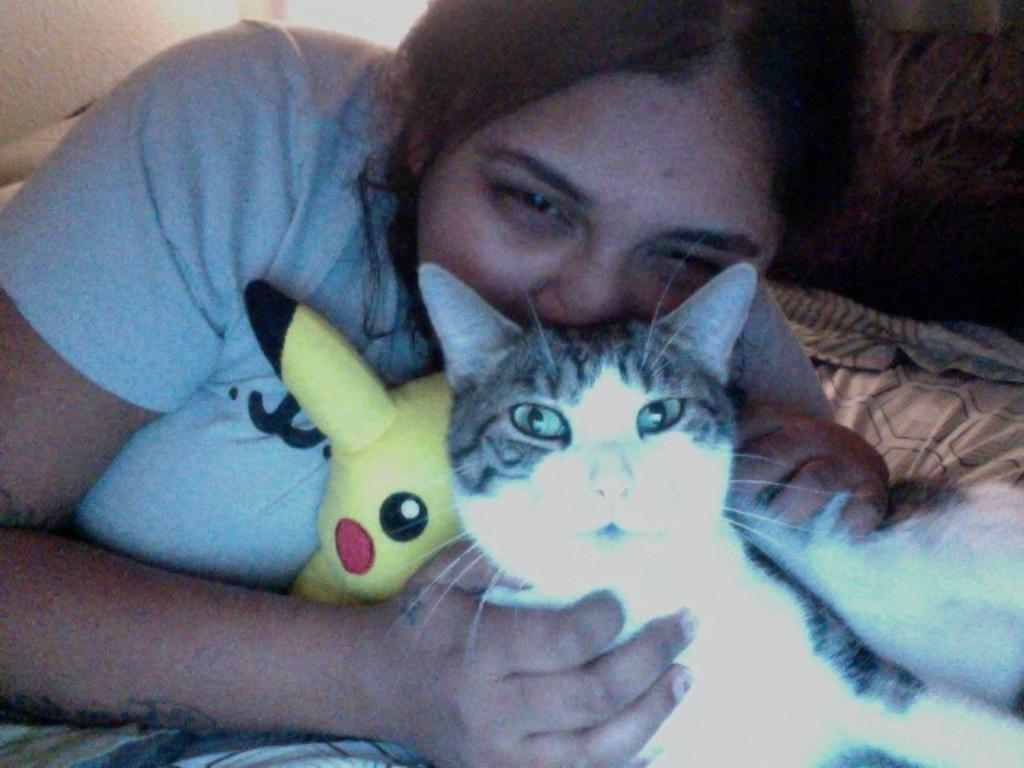Who is present in the image? There is a woman in the image. What is the woman holding in the image? The woman is holding a cat and a toy. Where is the woman located in the image? The woman is on a bed. What type of calculator is the woman using in the image? There is no calculator present in the image. What kind of suit is the woman wearing in the image? The woman is not wearing a suit in the image. 